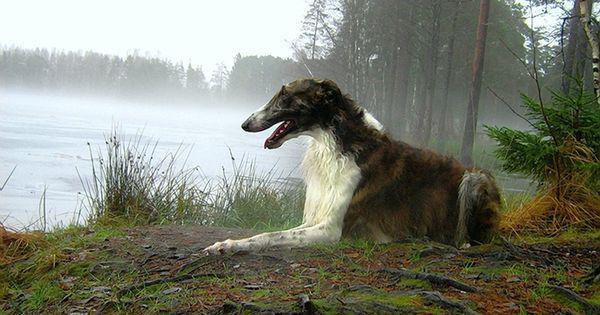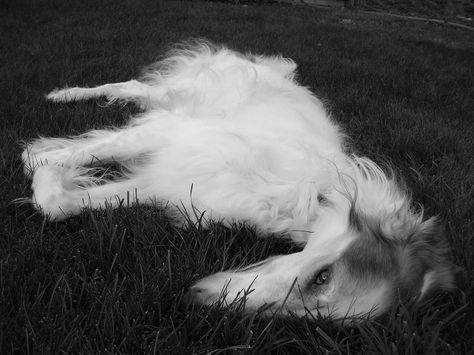The first image is the image on the left, the second image is the image on the right. Evaluate the accuracy of this statement regarding the images: "There are three dogs.". Is it true? Answer yes or no. No. The first image is the image on the left, the second image is the image on the right. Given the left and right images, does the statement "A single dog is lying down in the image on the right." hold true? Answer yes or no. Yes. 